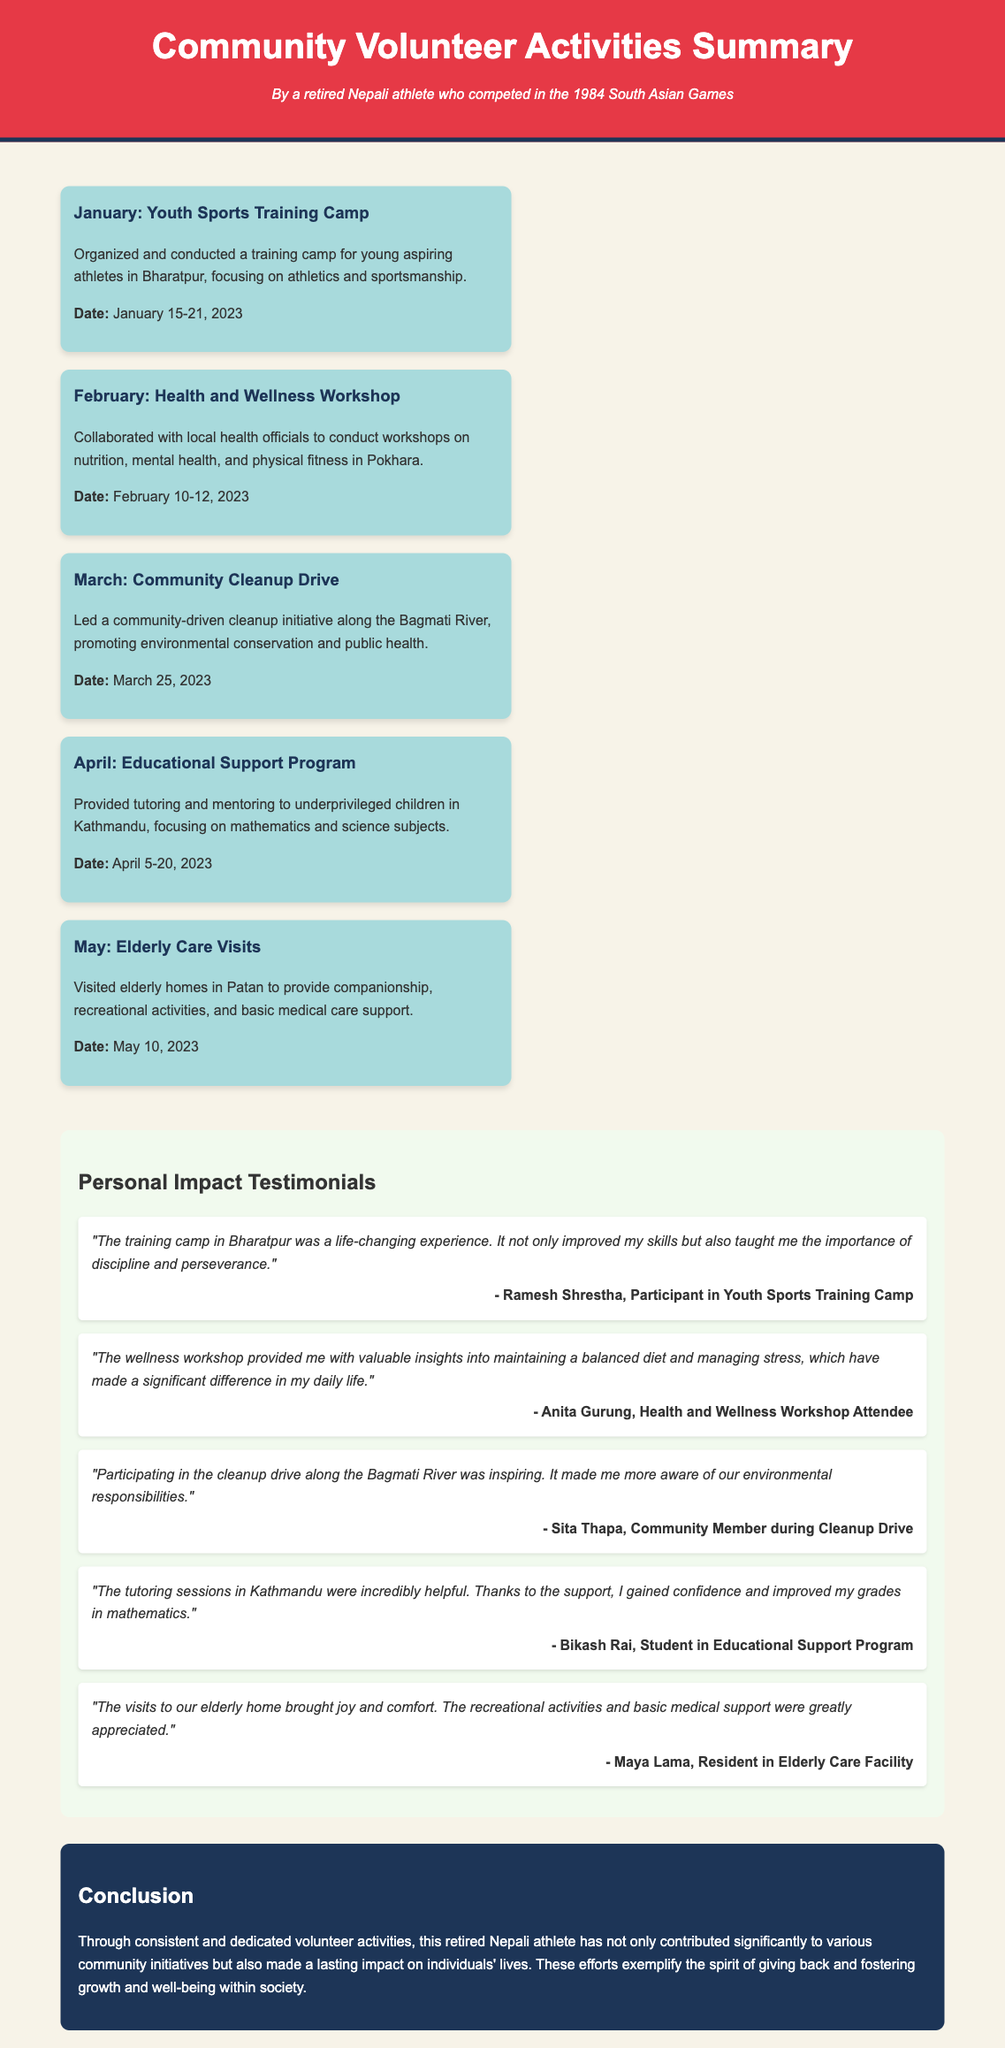What is the title of the document? The title of the document is displayed prominently in the header section.
Answer: Community Volunteer Activities Summary Who conducted the Youth Sports Training Camp? The document states that a retired Nepali athlete organized and conducted the camp.
Answer: A retired Nepali athlete When did the Health and Wellness Workshop take place? The date for the workshop is explicitly mentioned in the event description.
Answer: February 10-12, 2023 Which event focused on educational support? The event descriptions detail various activities, one of which specifically involves providing tutoring.
Answer: Educational Support Program What was a personal impact of the Youth Sports Training Camp according to a testimonial? The testimonial quotes emphasize the positive experiences and benefits from participating in the camp.
Answer: Life-changing experience How many community volunteer activities are described in the document? A count of the events listed will provide the total number of activities mentioned.
Answer: Five What is the main aim of the cleaning drive? The motivation for the cleanup initiative is highlighted in the event description.
Answer: Environmental conservation Who is Maya Lama? Maya Lama is identified as a resident in the elderly care facility who provided a testimonial.
Answer: Resident in Elderly Care Facility 